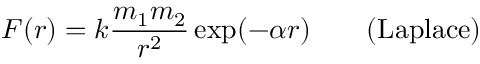<formula> <loc_0><loc_0><loc_500><loc_500>F ( r ) = k { \frac { m _ { 1 } m _ { 2 } } { r ^ { 2 } } } \exp ( - \alpha r ) \quad { ( L a p l a c e ) }</formula> 